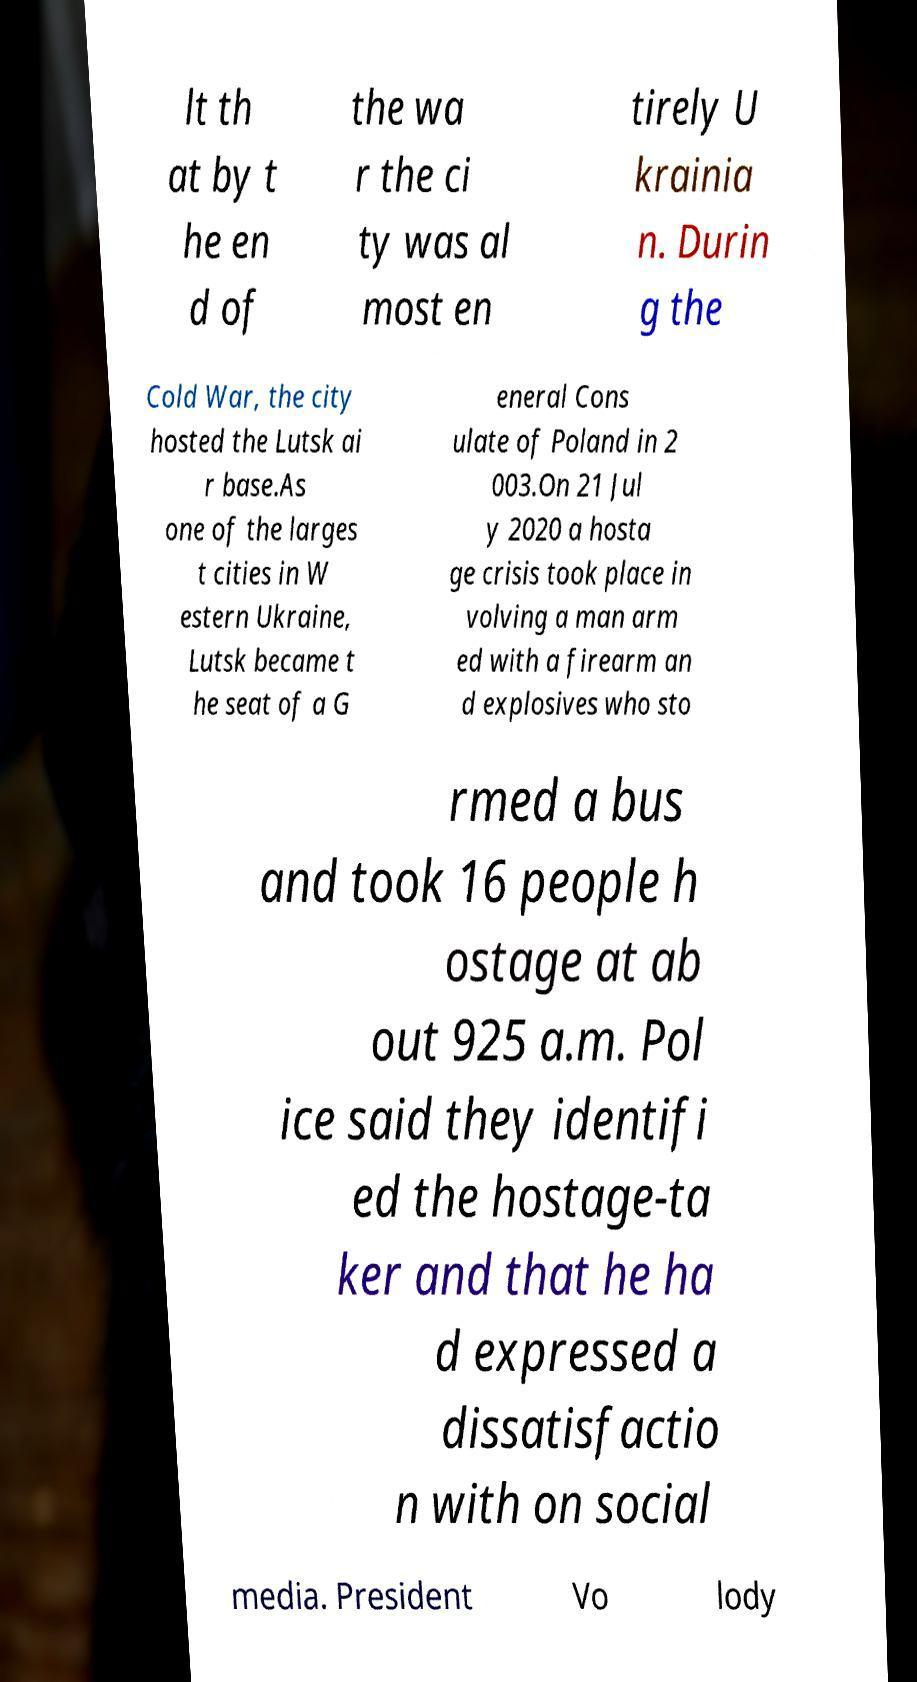Can you accurately transcribe the text from the provided image for me? lt th at by t he en d of the wa r the ci ty was al most en tirely U krainia n. Durin g the Cold War, the city hosted the Lutsk ai r base.As one of the larges t cities in W estern Ukraine, Lutsk became t he seat of a G eneral Cons ulate of Poland in 2 003.On 21 Jul y 2020 a hosta ge crisis took place in volving a man arm ed with a firearm an d explosives who sto rmed a bus and took 16 people h ostage at ab out 925 a.m. Pol ice said they identifi ed the hostage-ta ker and that he ha d expressed a dissatisfactio n with on social media. President Vo lody 